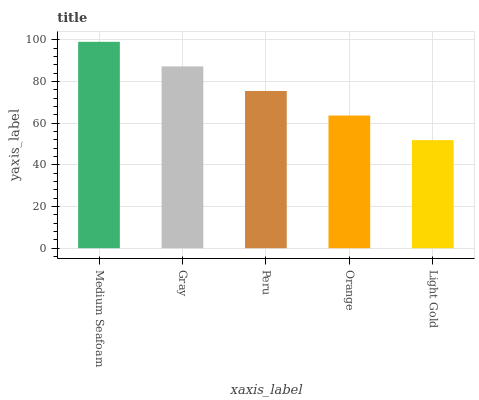Is Light Gold the minimum?
Answer yes or no. Yes. Is Medium Seafoam the maximum?
Answer yes or no. Yes. Is Gray the minimum?
Answer yes or no. No. Is Gray the maximum?
Answer yes or no. No. Is Medium Seafoam greater than Gray?
Answer yes or no. Yes. Is Gray less than Medium Seafoam?
Answer yes or no. Yes. Is Gray greater than Medium Seafoam?
Answer yes or no. No. Is Medium Seafoam less than Gray?
Answer yes or no. No. Is Peru the high median?
Answer yes or no. Yes. Is Peru the low median?
Answer yes or no. Yes. Is Orange the high median?
Answer yes or no. No. Is Orange the low median?
Answer yes or no. No. 